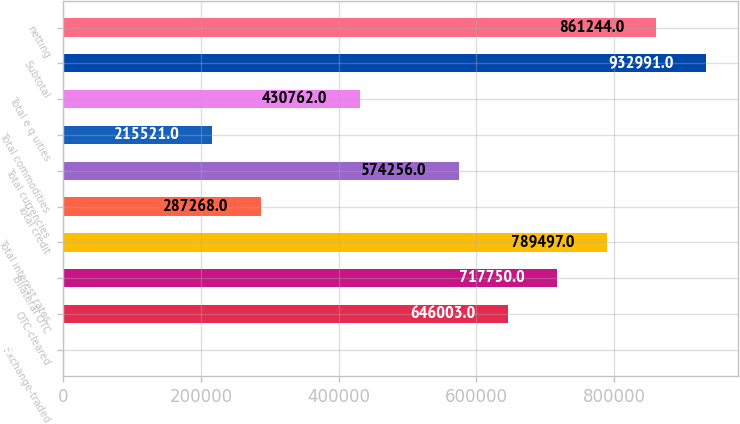Convert chart. <chart><loc_0><loc_0><loc_500><loc_500><bar_chart><fcel>Exchange-traded<fcel>OTC-cleared<fcel>Bilateral OTC<fcel>Total interest rates<fcel>Total credit<fcel>Total currencies<fcel>Total commodities<fcel>Total e q uities<fcel>Subtotal<fcel>netting<nl><fcel>280<fcel>646003<fcel>717750<fcel>789497<fcel>287268<fcel>574256<fcel>215521<fcel>430762<fcel>932991<fcel>861244<nl></chart> 